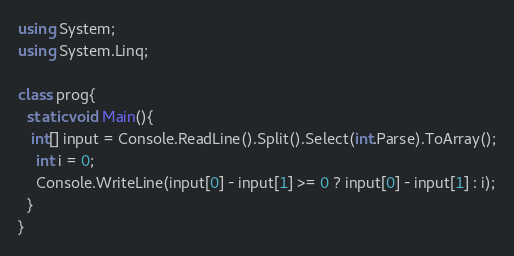Convert code to text. <code><loc_0><loc_0><loc_500><loc_500><_C#_>using System;
using System.Linq;

class prog{
  static void Main(){
   int[] input = Console.ReadLine().Split().Select(int.Parse).ToArray();
    int i = 0;
    Console.WriteLine(input[0] - input[1] >= 0 ? input[0] - input[1] : i);
  }
}</code> 